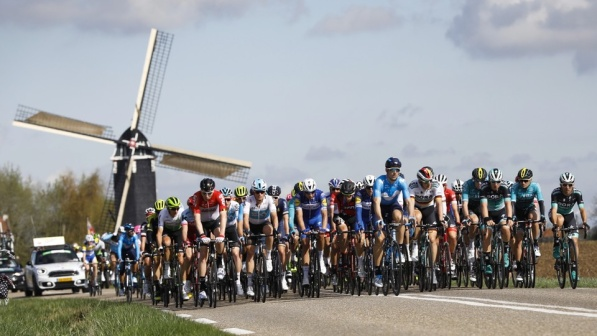Can you describe what stands out the most in this image? The most striking aspect of this image is the vibrant group of cyclists in the foreground, all riding together on a road. Their colorful jerseys and helmets stand out vividly against the more muted background of the road and sky. The tall, classic windmill to the left also catches the eye, with its white sails set against the clear, blue sky. What historical or cultural significance might the windmill have in this scene? Windmills are iconic structures in many European countries, especially in places like the Netherlands. They often symbolize the history of land reclamation and the inventive spirit of early industry. In this scene, the windmill adds a cultural and historical layer, reminding viewers of the ingenuity and heritage of the region while contrasting with the modernity and dynamic energy of the cycling event. Imagine you're narrating a documentary about this scene. What would you say? Here, in the tranquil expanse of the European countryside, modern athleticism meets historical charm. Cyclists from various regions race along this storied route, their bright jerseys a stark contrast to the serene landscape. As they pedal towards their goal, they pass by centuries-old windmills—silent sentinels of the past. These majestic structures, with their large, white sails, have stood the test of time and remain symbols of human ingenuity and perseverance. This moment, captured in a blend of color and motion, encapsulates a beautiful intersection of history, culture, and the unyielding spirit of competition. What would the windmill say if it could talk? If the windmill could speak, it might say: 'I have witnessed centuries of change, from the days when my sails first turned to harness the wind’s power, to now, as these cyclists race past in a blur of color and determination. I stand as a testament to human innovation and resilience, a silent observer of both quiet pastoral life and the vibrant pulse of modern events. Every rider that passes adds another chapter to my long and storied existence.' 